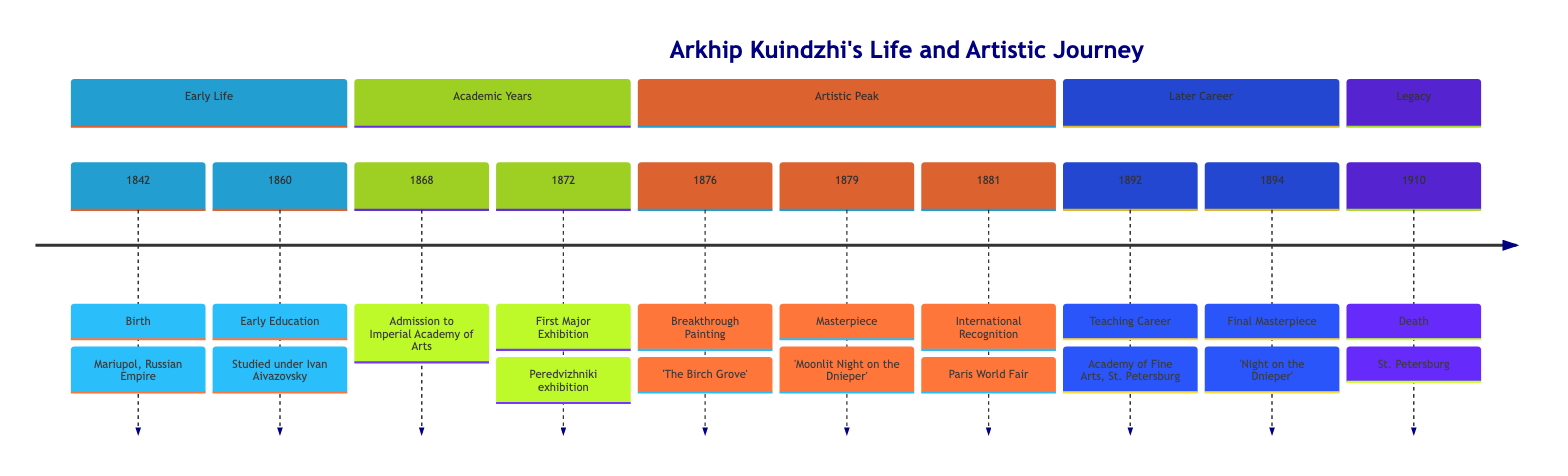What year did Arkhip Kuindzhi die? The timeline indicates that Arkhip Kuindzhi passed away in 1910. This is extracted directly from the "Legacy" section where the event is clearly stated.
Answer: 1910 What was the title of Kuindzhi's breakout painting? The timeline notes that the breakthrough painting is titled 'The Birch Grove', which is mentioned in connection to the year 1876.
Answer: 'The Birch Grove' In what year did Kuindzhi have his first major exhibition? According to the timeline, the first major exhibition took place in 1872. This event is specifically mentioned in the "Academic Years" section.
Answer: 1872 Which significant event occurred in 1881? The timeline details that in 1881, Kuindzhi participated in the Paris World Fair, which earned him international recognition. This information can be found in the "Artistic Peak" section.
Answer: Exhibition in Paris How many years passed between Kuindzhi's birth and his admission to the Imperial Academy of Arts? The timeline shows that Kuindzhi was born in 1842 and was admitted to the Imperial Academy of Arts in 1868. Subtracting these years results in 26 years.
Answer: 26 years What was the last painting completed by Kuindzhi? The timeline states that 'Night on the Dnieper' was completed in 1894, indicating it as his final masterpiece. This key detail is found in the "Later Career" section.
Answer: 'Night on the Dnieper' What major artistic milestone did Kuindzhi reach in 1879? In 1879, Kuindzhi produced 'Moonlit Night on the Dnieper', noted in the timeline as one of his most famous works, indicating an artistic peak.
Answer: 'Moonlit Night on the Dnieper' What did Kuindzhi do in 1892? The timeline indicates that in 1892, Kuindzhi began teaching at the Academy of Fine Arts in St. Petersburg, marking the beginning of his teaching career.
Answer: Teaching Career What artistic influence did Kuindzhi have? The timeline summarizes that he profoundly influenced Russian landscape painting, which is stated in the "Legacy" section.
Answer: Influential artist 